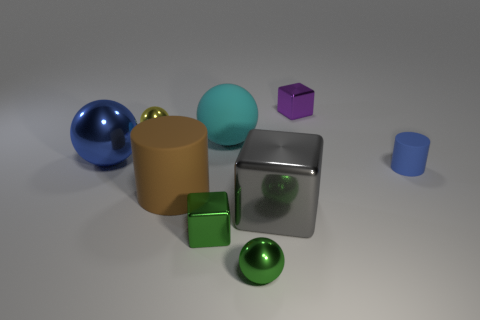There is a object that is the same color as the big metal ball; what size is it?
Give a very brief answer. Small. Do the small cylinder and the large metallic object behind the tiny cylinder have the same color?
Make the answer very short. Yes. Is the big metallic sphere the same color as the tiny matte thing?
Provide a succinct answer. Yes. Are there the same number of small matte cylinders to the left of the cyan rubber sphere and big brown metal objects?
Make the answer very short. Yes. How many objects are either brown objects or brown matte blocks?
Give a very brief answer. 1. What shape is the green thing that is right of the tiny green thing to the left of the cyan sphere?
Your answer should be very brief. Sphere. There is a blue thing that is made of the same material as the small yellow object; what is its shape?
Your answer should be very brief. Sphere. There is a sphere that is left of the small metal sphere that is on the left side of the tiny green metallic block; how big is it?
Make the answer very short. Large. There is a big cyan object; what shape is it?
Your answer should be very brief. Sphere. How many tiny objects are purple metal balls or brown rubber objects?
Ensure brevity in your answer.  0. 